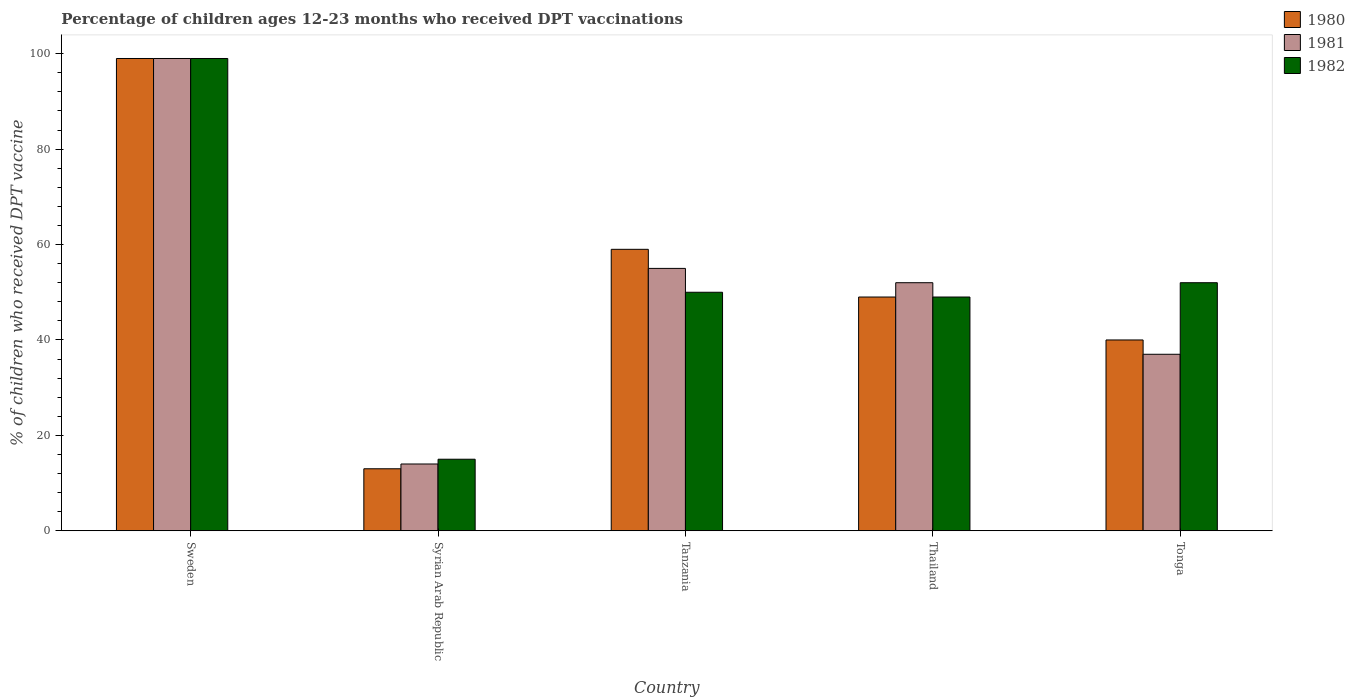How many different coloured bars are there?
Keep it short and to the point. 3. Are the number of bars per tick equal to the number of legend labels?
Provide a succinct answer. Yes. How many bars are there on the 3rd tick from the left?
Offer a terse response. 3. What is the label of the 1st group of bars from the left?
Offer a very short reply. Sweden. What is the percentage of children who received DPT vaccination in 1981 in Tonga?
Make the answer very short. 37. Across all countries, what is the maximum percentage of children who received DPT vaccination in 1980?
Give a very brief answer. 99. Across all countries, what is the minimum percentage of children who received DPT vaccination in 1982?
Provide a succinct answer. 15. In which country was the percentage of children who received DPT vaccination in 1980 maximum?
Make the answer very short. Sweden. In which country was the percentage of children who received DPT vaccination in 1981 minimum?
Make the answer very short. Syrian Arab Republic. What is the total percentage of children who received DPT vaccination in 1982 in the graph?
Keep it short and to the point. 265. What is the difference between the percentage of children who received DPT vaccination in 1982 in Sweden and that in Tanzania?
Ensure brevity in your answer.  49. What is the average percentage of children who received DPT vaccination in 1981 per country?
Provide a short and direct response. 51.4. What is the ratio of the percentage of children who received DPT vaccination in 1982 in Tanzania to that in Tonga?
Offer a very short reply. 0.96. Is the difference between the percentage of children who received DPT vaccination in 1982 in Sweden and Thailand greater than the difference between the percentage of children who received DPT vaccination in 1981 in Sweden and Thailand?
Your answer should be very brief. Yes. What is the difference between the highest and the second highest percentage of children who received DPT vaccination in 1980?
Provide a succinct answer. -40. What is the difference between the highest and the lowest percentage of children who received DPT vaccination in 1980?
Provide a succinct answer. 86. In how many countries, is the percentage of children who received DPT vaccination in 1982 greater than the average percentage of children who received DPT vaccination in 1982 taken over all countries?
Your answer should be very brief. 1. What does the 2nd bar from the right in Tonga represents?
Provide a succinct answer. 1981. What is the difference between two consecutive major ticks on the Y-axis?
Keep it short and to the point. 20. Are the values on the major ticks of Y-axis written in scientific E-notation?
Your answer should be very brief. No. Does the graph contain any zero values?
Keep it short and to the point. No. Does the graph contain grids?
Offer a very short reply. No. How many legend labels are there?
Your answer should be very brief. 3. What is the title of the graph?
Your response must be concise. Percentage of children ages 12-23 months who received DPT vaccinations. What is the label or title of the Y-axis?
Your answer should be compact. % of children who received DPT vaccine. What is the % of children who received DPT vaccine of 1980 in Syrian Arab Republic?
Offer a terse response. 13. What is the % of children who received DPT vaccine of 1981 in Syrian Arab Republic?
Your answer should be very brief. 14. What is the % of children who received DPT vaccine in 1981 in Tanzania?
Offer a terse response. 55. What is the % of children who received DPT vaccine of 1980 in Thailand?
Your answer should be very brief. 49. What is the % of children who received DPT vaccine of 1981 in Thailand?
Provide a short and direct response. 52. What is the % of children who received DPT vaccine of 1982 in Thailand?
Your answer should be very brief. 49. What is the % of children who received DPT vaccine in 1981 in Tonga?
Your response must be concise. 37. Across all countries, what is the maximum % of children who received DPT vaccine of 1980?
Offer a very short reply. 99. Across all countries, what is the minimum % of children who received DPT vaccine of 1980?
Keep it short and to the point. 13. Across all countries, what is the minimum % of children who received DPT vaccine in 1981?
Give a very brief answer. 14. What is the total % of children who received DPT vaccine in 1980 in the graph?
Your response must be concise. 260. What is the total % of children who received DPT vaccine of 1981 in the graph?
Give a very brief answer. 257. What is the total % of children who received DPT vaccine of 1982 in the graph?
Ensure brevity in your answer.  265. What is the difference between the % of children who received DPT vaccine of 1980 in Sweden and that in Syrian Arab Republic?
Provide a succinct answer. 86. What is the difference between the % of children who received DPT vaccine of 1981 in Sweden and that in Syrian Arab Republic?
Your answer should be compact. 85. What is the difference between the % of children who received DPT vaccine in 1980 in Sweden and that in Tanzania?
Make the answer very short. 40. What is the difference between the % of children who received DPT vaccine of 1981 in Sweden and that in Thailand?
Your answer should be compact. 47. What is the difference between the % of children who received DPT vaccine of 1982 in Sweden and that in Thailand?
Give a very brief answer. 50. What is the difference between the % of children who received DPT vaccine of 1980 in Sweden and that in Tonga?
Keep it short and to the point. 59. What is the difference between the % of children who received DPT vaccine of 1982 in Sweden and that in Tonga?
Offer a terse response. 47. What is the difference between the % of children who received DPT vaccine of 1980 in Syrian Arab Republic and that in Tanzania?
Ensure brevity in your answer.  -46. What is the difference between the % of children who received DPT vaccine of 1981 in Syrian Arab Republic and that in Tanzania?
Ensure brevity in your answer.  -41. What is the difference between the % of children who received DPT vaccine of 1982 in Syrian Arab Republic and that in Tanzania?
Provide a short and direct response. -35. What is the difference between the % of children who received DPT vaccine of 1980 in Syrian Arab Republic and that in Thailand?
Give a very brief answer. -36. What is the difference between the % of children who received DPT vaccine of 1981 in Syrian Arab Republic and that in Thailand?
Your response must be concise. -38. What is the difference between the % of children who received DPT vaccine of 1982 in Syrian Arab Republic and that in Thailand?
Your answer should be compact. -34. What is the difference between the % of children who received DPT vaccine in 1980 in Syrian Arab Republic and that in Tonga?
Make the answer very short. -27. What is the difference between the % of children who received DPT vaccine of 1982 in Syrian Arab Republic and that in Tonga?
Your response must be concise. -37. What is the difference between the % of children who received DPT vaccine in 1980 in Tanzania and that in Thailand?
Offer a very short reply. 10. What is the difference between the % of children who received DPT vaccine in 1981 in Tanzania and that in Thailand?
Your answer should be very brief. 3. What is the difference between the % of children who received DPT vaccine in 1981 in Tanzania and that in Tonga?
Ensure brevity in your answer.  18. What is the difference between the % of children who received DPT vaccine in 1982 in Tanzania and that in Tonga?
Offer a very short reply. -2. What is the difference between the % of children who received DPT vaccine in 1982 in Thailand and that in Tonga?
Make the answer very short. -3. What is the difference between the % of children who received DPT vaccine in 1980 in Sweden and the % of children who received DPT vaccine in 1981 in Syrian Arab Republic?
Make the answer very short. 85. What is the difference between the % of children who received DPT vaccine in 1980 in Sweden and the % of children who received DPT vaccine in 1982 in Syrian Arab Republic?
Ensure brevity in your answer.  84. What is the difference between the % of children who received DPT vaccine in 1980 in Sweden and the % of children who received DPT vaccine in 1981 in Tanzania?
Offer a terse response. 44. What is the difference between the % of children who received DPT vaccine of 1980 in Sweden and the % of children who received DPT vaccine of 1982 in Tanzania?
Make the answer very short. 49. What is the difference between the % of children who received DPT vaccine in 1980 in Sweden and the % of children who received DPT vaccine in 1982 in Thailand?
Keep it short and to the point. 50. What is the difference between the % of children who received DPT vaccine in 1981 in Sweden and the % of children who received DPT vaccine in 1982 in Thailand?
Keep it short and to the point. 50. What is the difference between the % of children who received DPT vaccine of 1980 in Sweden and the % of children who received DPT vaccine of 1981 in Tonga?
Your answer should be very brief. 62. What is the difference between the % of children who received DPT vaccine in 1981 in Sweden and the % of children who received DPT vaccine in 1982 in Tonga?
Provide a short and direct response. 47. What is the difference between the % of children who received DPT vaccine of 1980 in Syrian Arab Republic and the % of children who received DPT vaccine of 1981 in Tanzania?
Your response must be concise. -42. What is the difference between the % of children who received DPT vaccine in 1980 in Syrian Arab Republic and the % of children who received DPT vaccine in 1982 in Tanzania?
Make the answer very short. -37. What is the difference between the % of children who received DPT vaccine of 1981 in Syrian Arab Republic and the % of children who received DPT vaccine of 1982 in Tanzania?
Your answer should be very brief. -36. What is the difference between the % of children who received DPT vaccine of 1980 in Syrian Arab Republic and the % of children who received DPT vaccine of 1981 in Thailand?
Your answer should be compact. -39. What is the difference between the % of children who received DPT vaccine of 1980 in Syrian Arab Republic and the % of children who received DPT vaccine of 1982 in Thailand?
Make the answer very short. -36. What is the difference between the % of children who received DPT vaccine of 1981 in Syrian Arab Republic and the % of children who received DPT vaccine of 1982 in Thailand?
Provide a succinct answer. -35. What is the difference between the % of children who received DPT vaccine in 1980 in Syrian Arab Republic and the % of children who received DPT vaccine in 1982 in Tonga?
Give a very brief answer. -39. What is the difference between the % of children who received DPT vaccine in 1981 in Syrian Arab Republic and the % of children who received DPT vaccine in 1982 in Tonga?
Give a very brief answer. -38. What is the difference between the % of children who received DPT vaccine in 1980 in Tanzania and the % of children who received DPT vaccine in 1981 in Thailand?
Provide a short and direct response. 7. What is the difference between the % of children who received DPT vaccine of 1980 in Tanzania and the % of children who received DPT vaccine of 1981 in Tonga?
Your response must be concise. 22. What is the difference between the % of children who received DPT vaccine of 1980 in Thailand and the % of children who received DPT vaccine of 1981 in Tonga?
Offer a very short reply. 12. What is the average % of children who received DPT vaccine of 1981 per country?
Provide a short and direct response. 51.4. What is the difference between the % of children who received DPT vaccine of 1980 and % of children who received DPT vaccine of 1981 in Sweden?
Ensure brevity in your answer.  0. What is the difference between the % of children who received DPT vaccine in 1980 and % of children who received DPT vaccine in 1982 in Sweden?
Your answer should be compact. 0. What is the difference between the % of children who received DPT vaccine of 1981 and % of children who received DPT vaccine of 1982 in Sweden?
Ensure brevity in your answer.  0. What is the difference between the % of children who received DPT vaccine of 1980 and % of children who received DPT vaccine of 1981 in Syrian Arab Republic?
Make the answer very short. -1. What is the difference between the % of children who received DPT vaccine of 1980 and % of children who received DPT vaccine of 1981 in Tanzania?
Your answer should be very brief. 4. What is the difference between the % of children who received DPT vaccine of 1981 and % of children who received DPT vaccine of 1982 in Tanzania?
Your response must be concise. 5. What is the difference between the % of children who received DPT vaccine of 1980 and % of children who received DPT vaccine of 1981 in Thailand?
Keep it short and to the point. -3. What is the difference between the % of children who received DPT vaccine in 1980 and % of children who received DPT vaccine in 1982 in Thailand?
Provide a short and direct response. 0. What is the difference between the % of children who received DPT vaccine in 1981 and % of children who received DPT vaccine in 1982 in Thailand?
Your answer should be compact. 3. What is the difference between the % of children who received DPT vaccine of 1980 and % of children who received DPT vaccine of 1981 in Tonga?
Provide a succinct answer. 3. What is the ratio of the % of children who received DPT vaccine of 1980 in Sweden to that in Syrian Arab Republic?
Provide a succinct answer. 7.62. What is the ratio of the % of children who received DPT vaccine in 1981 in Sweden to that in Syrian Arab Republic?
Ensure brevity in your answer.  7.07. What is the ratio of the % of children who received DPT vaccine of 1982 in Sweden to that in Syrian Arab Republic?
Your response must be concise. 6.6. What is the ratio of the % of children who received DPT vaccine of 1980 in Sweden to that in Tanzania?
Your response must be concise. 1.68. What is the ratio of the % of children who received DPT vaccine of 1982 in Sweden to that in Tanzania?
Provide a short and direct response. 1.98. What is the ratio of the % of children who received DPT vaccine in 1980 in Sweden to that in Thailand?
Your response must be concise. 2.02. What is the ratio of the % of children who received DPT vaccine in 1981 in Sweden to that in Thailand?
Provide a succinct answer. 1.9. What is the ratio of the % of children who received DPT vaccine of 1982 in Sweden to that in Thailand?
Provide a short and direct response. 2.02. What is the ratio of the % of children who received DPT vaccine in 1980 in Sweden to that in Tonga?
Your response must be concise. 2.48. What is the ratio of the % of children who received DPT vaccine in 1981 in Sweden to that in Tonga?
Your answer should be very brief. 2.68. What is the ratio of the % of children who received DPT vaccine in 1982 in Sweden to that in Tonga?
Provide a short and direct response. 1.9. What is the ratio of the % of children who received DPT vaccine in 1980 in Syrian Arab Republic to that in Tanzania?
Ensure brevity in your answer.  0.22. What is the ratio of the % of children who received DPT vaccine in 1981 in Syrian Arab Republic to that in Tanzania?
Provide a succinct answer. 0.25. What is the ratio of the % of children who received DPT vaccine in 1980 in Syrian Arab Republic to that in Thailand?
Ensure brevity in your answer.  0.27. What is the ratio of the % of children who received DPT vaccine of 1981 in Syrian Arab Republic to that in Thailand?
Provide a short and direct response. 0.27. What is the ratio of the % of children who received DPT vaccine in 1982 in Syrian Arab Republic to that in Thailand?
Make the answer very short. 0.31. What is the ratio of the % of children who received DPT vaccine of 1980 in Syrian Arab Republic to that in Tonga?
Give a very brief answer. 0.33. What is the ratio of the % of children who received DPT vaccine of 1981 in Syrian Arab Republic to that in Tonga?
Your answer should be very brief. 0.38. What is the ratio of the % of children who received DPT vaccine of 1982 in Syrian Arab Republic to that in Tonga?
Your response must be concise. 0.29. What is the ratio of the % of children who received DPT vaccine in 1980 in Tanzania to that in Thailand?
Provide a succinct answer. 1.2. What is the ratio of the % of children who received DPT vaccine of 1981 in Tanzania to that in Thailand?
Make the answer very short. 1.06. What is the ratio of the % of children who received DPT vaccine of 1982 in Tanzania to that in Thailand?
Offer a terse response. 1.02. What is the ratio of the % of children who received DPT vaccine of 1980 in Tanzania to that in Tonga?
Provide a short and direct response. 1.48. What is the ratio of the % of children who received DPT vaccine of 1981 in Tanzania to that in Tonga?
Ensure brevity in your answer.  1.49. What is the ratio of the % of children who received DPT vaccine in 1982 in Tanzania to that in Tonga?
Ensure brevity in your answer.  0.96. What is the ratio of the % of children who received DPT vaccine of 1980 in Thailand to that in Tonga?
Your response must be concise. 1.23. What is the ratio of the % of children who received DPT vaccine in 1981 in Thailand to that in Tonga?
Provide a short and direct response. 1.41. What is the ratio of the % of children who received DPT vaccine of 1982 in Thailand to that in Tonga?
Offer a very short reply. 0.94. What is the difference between the highest and the second highest % of children who received DPT vaccine of 1980?
Ensure brevity in your answer.  40. What is the difference between the highest and the second highest % of children who received DPT vaccine of 1981?
Give a very brief answer. 44. What is the difference between the highest and the lowest % of children who received DPT vaccine of 1981?
Offer a very short reply. 85. 